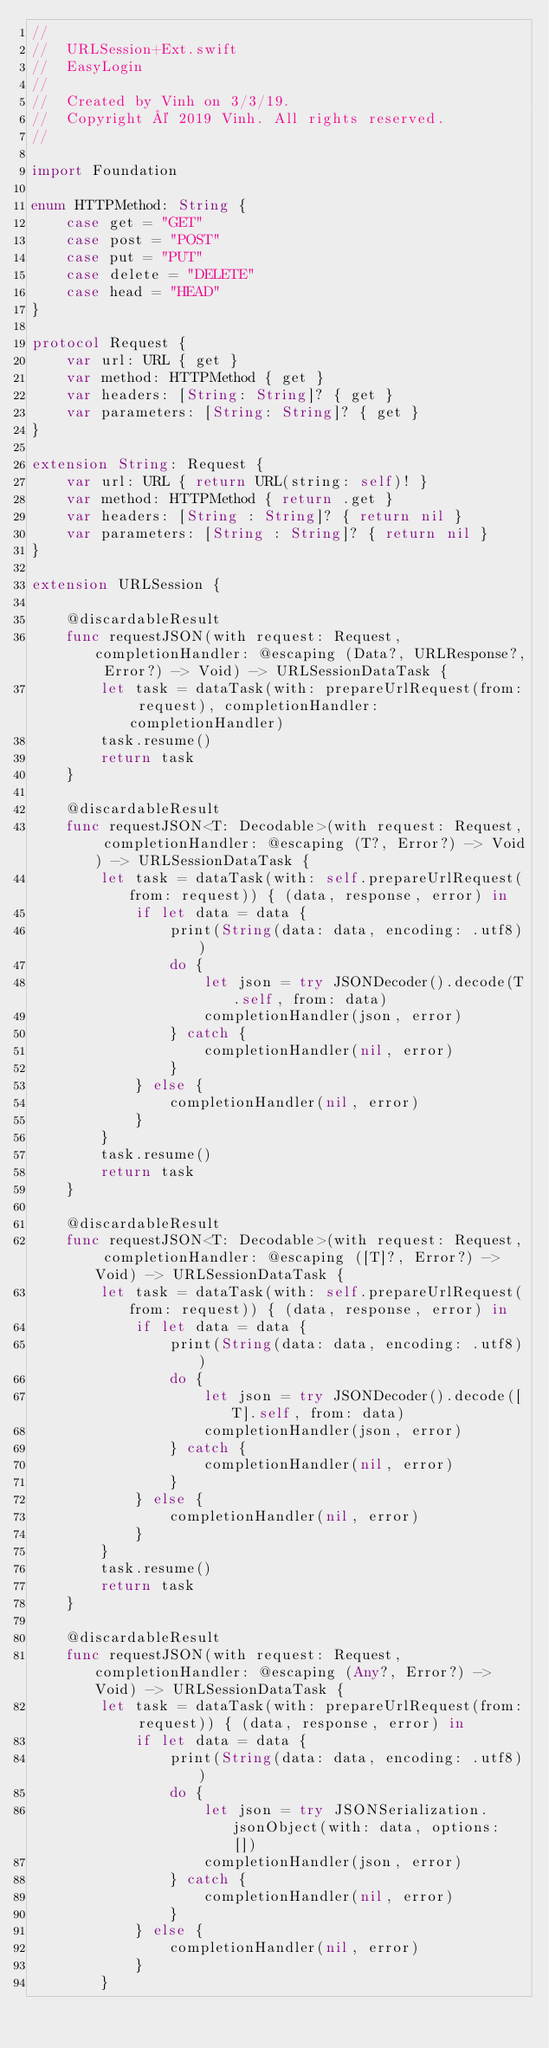<code> <loc_0><loc_0><loc_500><loc_500><_Swift_>//
//  URLSession+Ext.swift
//  EasyLogin
//
//  Created by Vinh on 3/3/19.
//  Copyright © 2019 Vinh. All rights reserved.
//

import Foundation

enum HTTPMethod: String {
    case get = "GET"
    case post = "POST"
    case put = "PUT"
    case delete = "DELETE"
    case head = "HEAD"
}

protocol Request {
    var url: URL { get }
    var method: HTTPMethod { get }
    var headers: [String: String]? { get }
    var parameters: [String: String]? { get }
}

extension String: Request {
    var url: URL { return URL(string: self)! }
    var method: HTTPMethod { return .get }
    var headers: [String : String]? { return nil }
    var parameters: [String : String]? { return nil }
}

extension URLSession {
    
    @discardableResult
    func requestJSON(with request: Request, completionHandler: @escaping (Data?, URLResponse?, Error?) -> Void) -> URLSessionDataTask {
        let task = dataTask(with: prepareUrlRequest(from: request), completionHandler: completionHandler)
        task.resume()
        return task
    }
    
    @discardableResult
    func requestJSON<T: Decodable>(with request: Request, completionHandler: @escaping (T?, Error?) -> Void) -> URLSessionDataTask {
        let task = dataTask(with: self.prepareUrlRequest(from: request)) { (data, response, error) in
            if let data = data {
                print(String(data: data, encoding: .utf8))
                do {
                    let json = try JSONDecoder().decode(T.self, from: data)
                    completionHandler(json, error)
                } catch {
                    completionHandler(nil, error)
                }
            } else {
                completionHandler(nil, error)
            }
        }
        task.resume()
        return task
    }
    
    @discardableResult
    func requestJSON<T: Decodable>(with request: Request, completionHandler: @escaping ([T]?, Error?) -> Void) -> URLSessionDataTask {
        let task = dataTask(with: self.prepareUrlRequest(from: request)) { (data, response, error) in
            if let data = data {
                print(String(data: data, encoding: .utf8))
                do {
                    let json = try JSONDecoder().decode([T].self, from: data)
                    completionHandler(json, error)
                } catch {
                    completionHandler(nil, error)
                }
            } else {
                completionHandler(nil, error)
            }
        }
        task.resume()
        return task
    }
    
    @discardableResult
    func requestJSON(with request: Request, completionHandler: @escaping (Any?, Error?) -> Void) -> URLSessionDataTask {
        let task = dataTask(with: prepareUrlRequest(from: request)) { (data, response, error) in
            if let data = data {
                print(String(data: data, encoding: .utf8))
                do {
                    let json = try JSONSerialization.jsonObject(with: data, options: [])
                    completionHandler(json, error)
                } catch {
                    completionHandler(nil, error)
                }
            } else {
                completionHandler(nil, error)
            }
        }</code> 